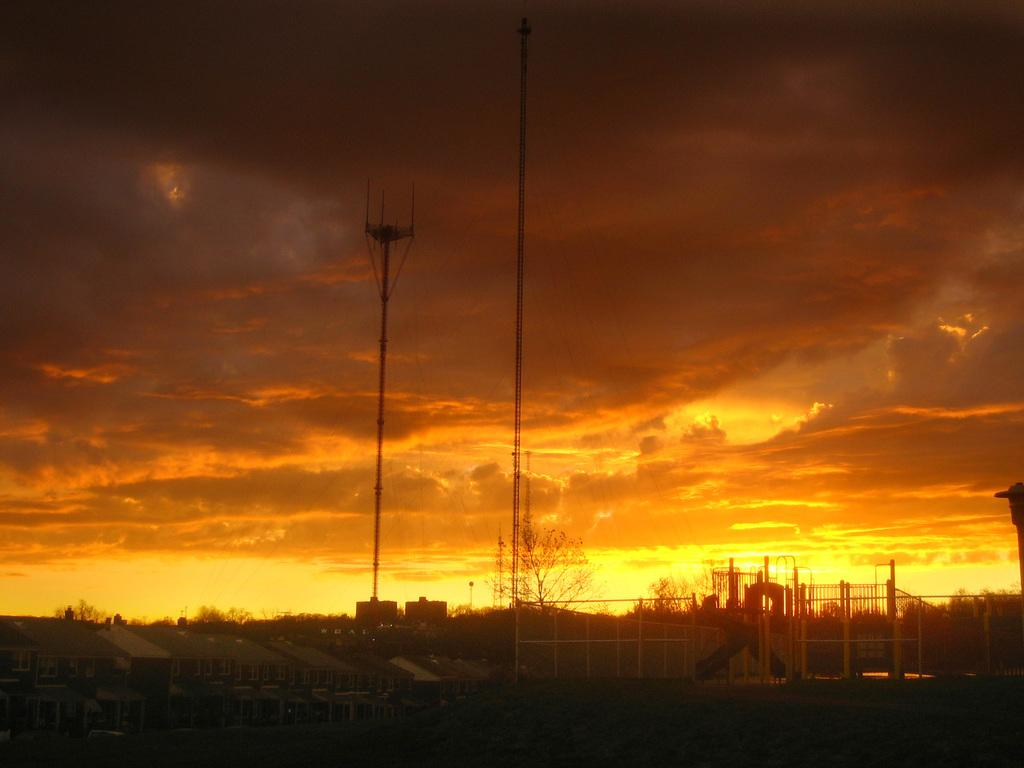What type of natural elements can be seen in the image? There are trees in the image. What type of man-made structures are visible in the image? There are buildings in the image. What are the tall, thin objects in the image? There are poles in the image. What is visible in the sky in the image? There are clouds in the sky. What type of paste is being used to guide the rate of the clouds in the image? There is no paste or guidance of clouds mentioned in the image; it simply shows trees, buildings, poles, and clouds. 